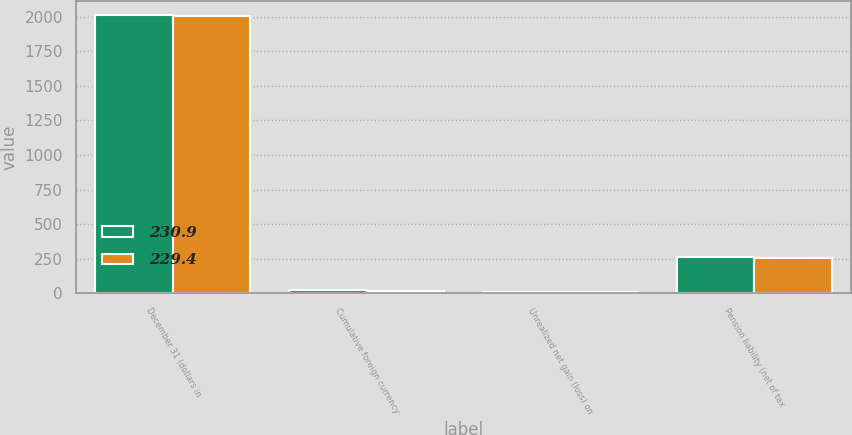Convert chart to OTSL. <chart><loc_0><loc_0><loc_500><loc_500><stacked_bar_chart><ecel><fcel>December 31 (dollars in<fcel>Cumulative foreign currency<fcel>Unrealized net gain (loss) on<fcel>Pension liability (net of tax<nl><fcel>230.9<fcel>2010<fcel>23.7<fcel>10.7<fcel>263.8<nl><fcel>229.4<fcel>2009<fcel>16.4<fcel>10.9<fcel>258.2<nl></chart> 